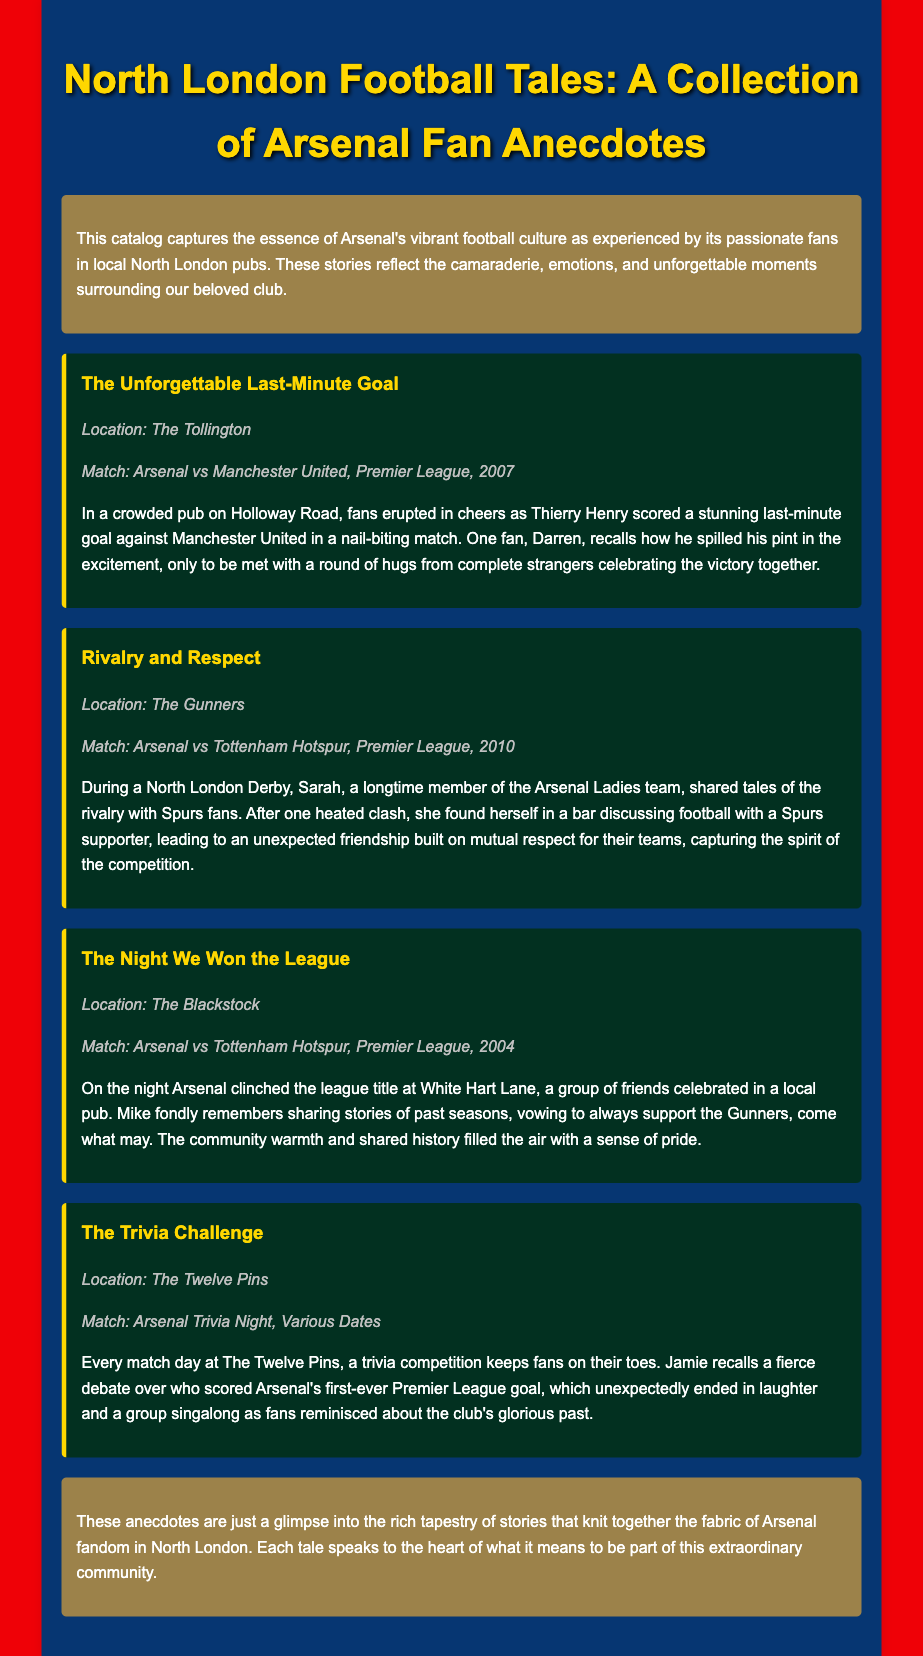What is the title of the collection? The title is mentioned at the top of the document, introducing the subject of the catalog.
Answer: North London Football Tales: A Collection of Arsenal Fan Anecdotes Where did Darren spill his pint? The location of the incident is specified in the first anecdote about the last-minute goal.
Answer: The Tollington What match is associated with Sarah's story? The anecdote includes a specific match that took place during a rivalry game.
Answer: Arsenal vs Tottenham Hotspur, Premier League, 2010 Which pub hosts a trivia competition every match day? The document specifies the venue for the trivia competition related to Arsenal matches.
Answer: The Twelve Pins How many anecdotes are presented in the document? The total number of anecdotes can be quickly counted from the document sections.
Answer: Four What historic event does Mike reminisce about? The story describes a specific moment in Arsenal's history that was celebrated.
Answer: The night Arsenal clinched the league title Which anecdote mentions a singalong? This detail is mentioned in the anecdote discussing a trivia challenge on match days.
Answer: The Trivia Challenge What color is the background of the document? The overall background color is highlighted as part of the design in the document style.
Answer: Red 